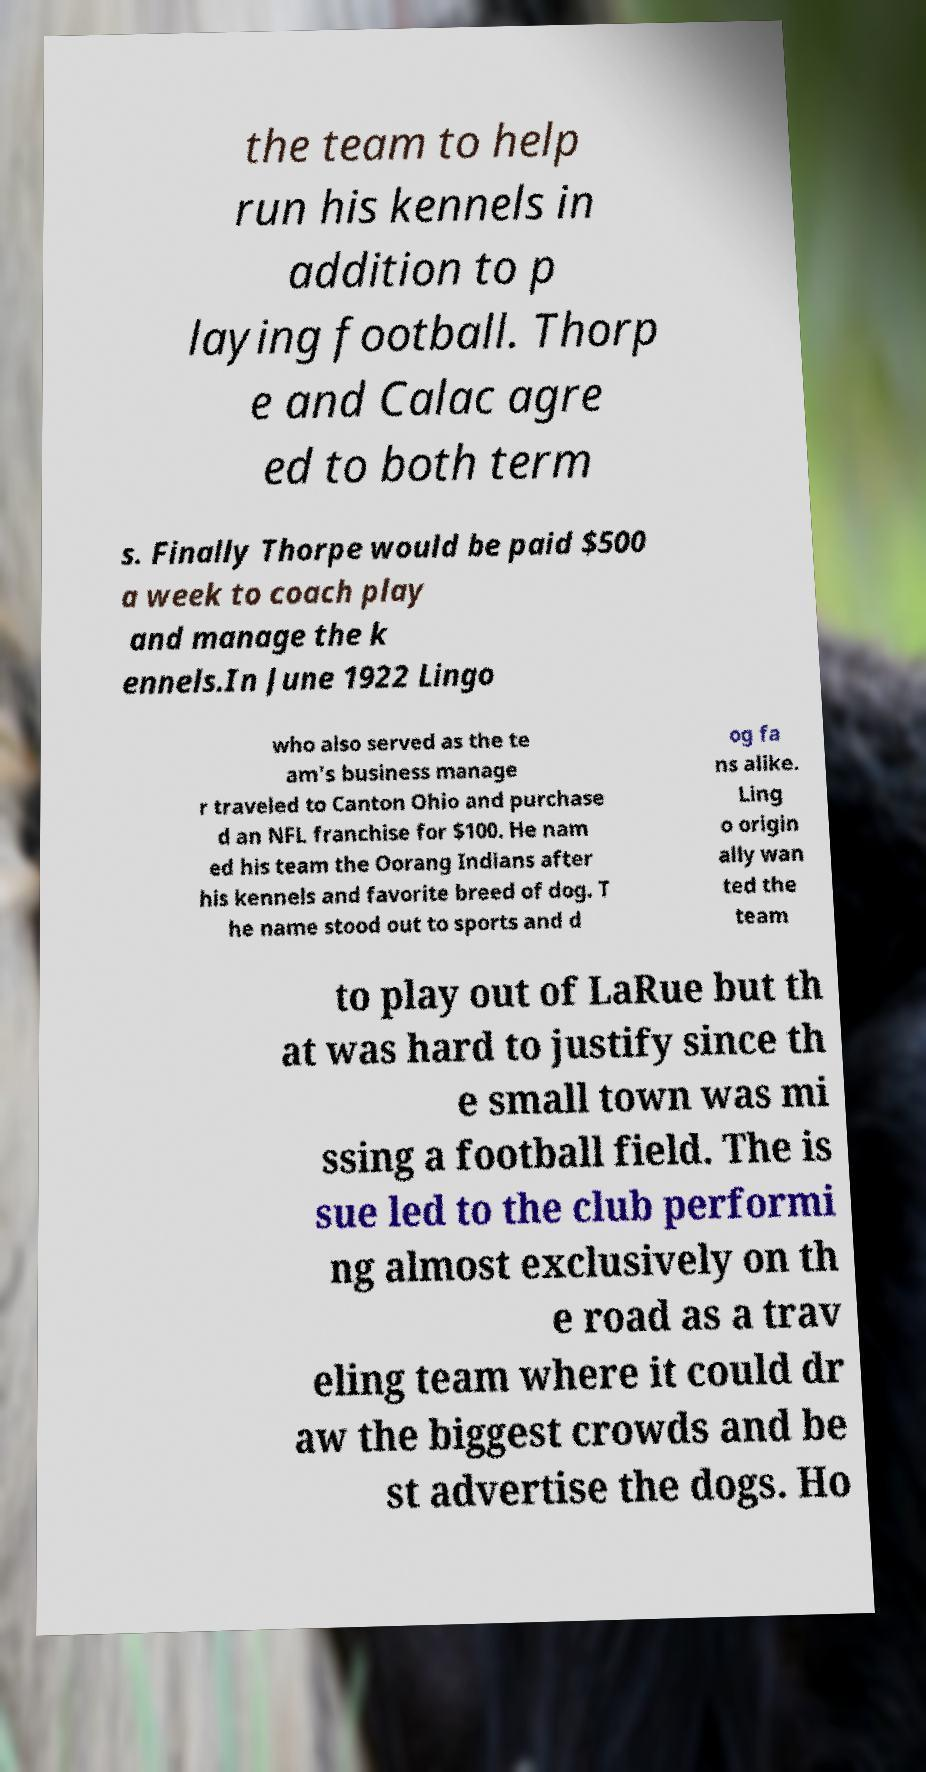There's text embedded in this image that I need extracted. Can you transcribe it verbatim? the team to help run his kennels in addition to p laying football. Thorp e and Calac agre ed to both term s. Finally Thorpe would be paid $500 a week to coach play and manage the k ennels.In June 1922 Lingo who also served as the te am's business manage r traveled to Canton Ohio and purchase d an NFL franchise for $100. He nam ed his team the Oorang Indians after his kennels and favorite breed of dog. T he name stood out to sports and d og fa ns alike. Ling o origin ally wan ted the team to play out of LaRue but th at was hard to justify since th e small town was mi ssing a football field. The is sue led to the club performi ng almost exclusively on th e road as a trav eling team where it could dr aw the biggest crowds and be st advertise the dogs. Ho 